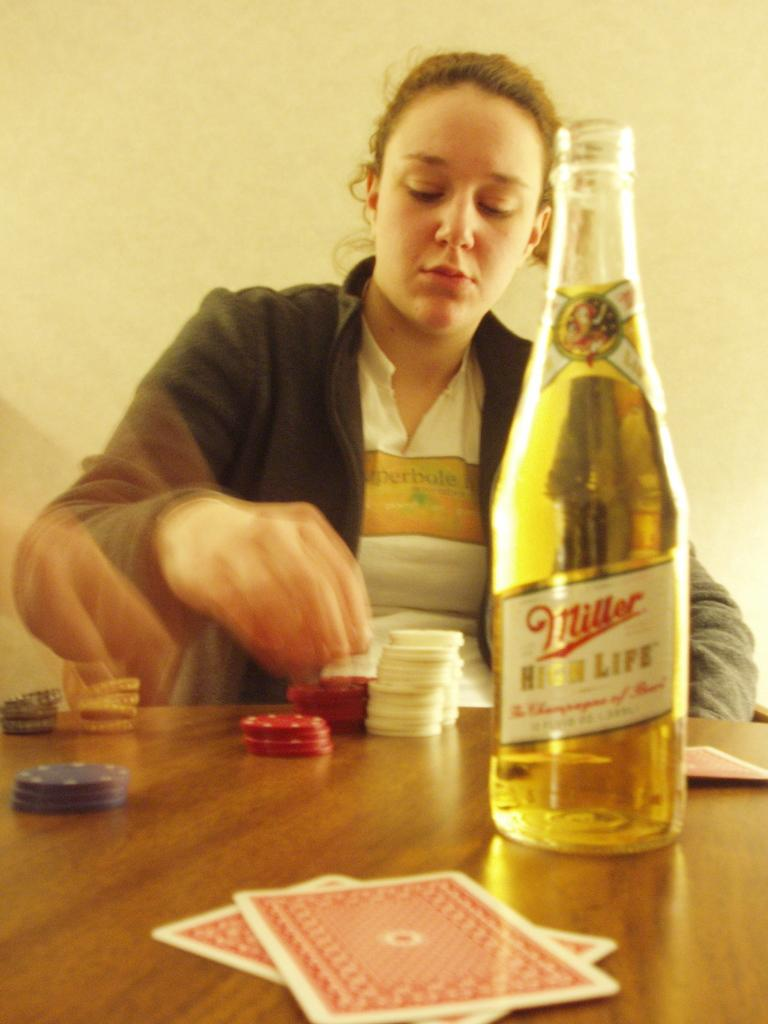<image>
Relay a brief, clear account of the picture shown. The woman is playing with the poker chips and drinking Miller High Life. 